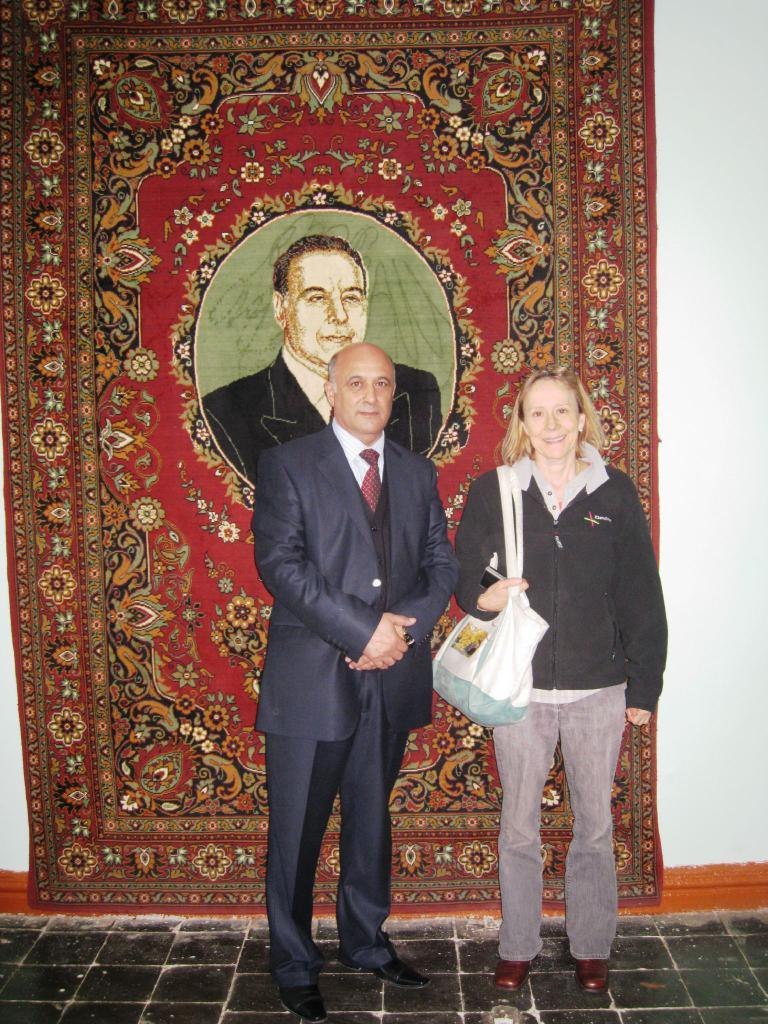What is the main subject in the foreground of the image? There is a woman standing in the foreground of the image. What is the woman wearing? The woman is wearing bags. Who else is present in the foreground of the image? There is a man standing in the foreground of the image. What is the man's position in relation to the floor? The man is standing on the floor. What can be seen in the background of the image? There is a carpet and a wall in the background of the image. What type of feeling does the property evoke in the image? There is no mention of a property or any feelings associated with it in the image. The image only shows a woman and a man standing in the foreground, with a carpet and a wall in the background. --- Facts: 1. There is a person sitting on a chair in the image. 2. The person is holding a book. 3. The book has a blue cover. 4. There is a table next to the chair. 5. There is a lamp on the table. Absurd Topics: animal, ocean, mountain Conversation: What is the person in the image doing? The person is sitting on a chair in the image. What is the person holding? The person is holding a book. What color is the book's cover? The book has a blue cover. What is located next to the chair? There is a table next to the chair. What object is on the table? There is a lamp on the table. Reasoning: Let's think step by step in order to produce the conversation. We start by identifying the main subject in the image, which is the person sitting on a chair. Then, we describe what the person is holding, which is a book with a blue cover. Next, we mention the objects located near the chair, which are a table and a lamp. Absurd Question/Answer: What type of animal can be seen swimming in the ocean in the image? There is no animal or ocean present in the image. The image only shows a person sitting on a chair, holding a book with a blue cover, and a table with a lamp on it. 